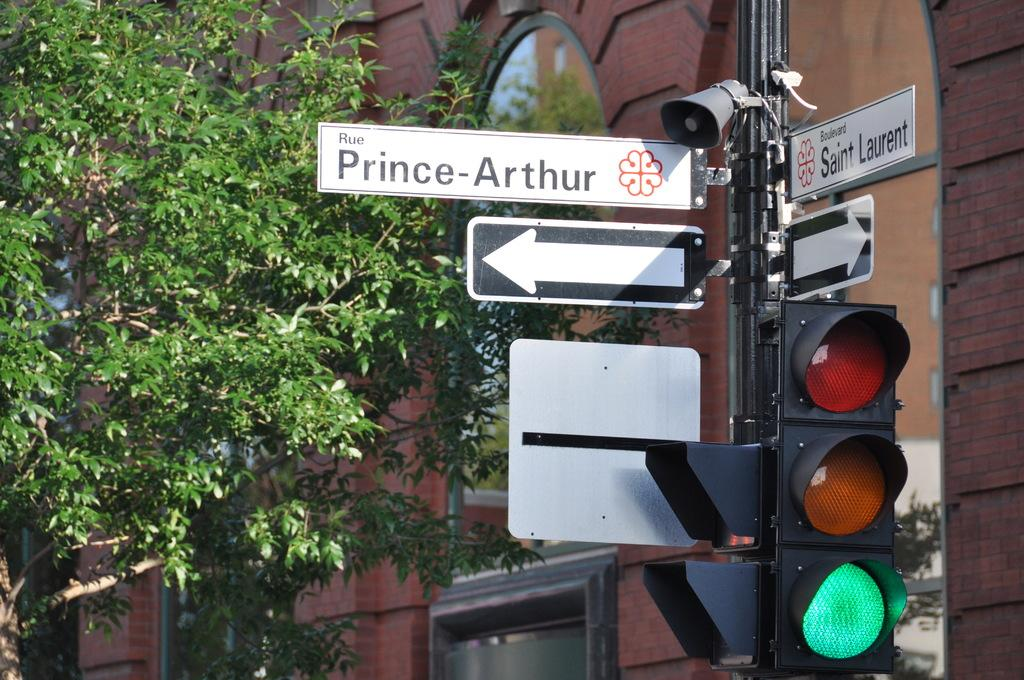<image>
Write a terse but informative summary of the picture. A green traffic signal at the corner of Sanit Laurant and Rue Prince-Arthur. 